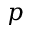<formula> <loc_0><loc_0><loc_500><loc_500>p</formula> 